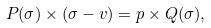Convert formula to latex. <formula><loc_0><loc_0><loc_500><loc_500>P ( \sigma ) \times ( \sigma - v ) = p \times Q ( \sigma ) ,</formula> 